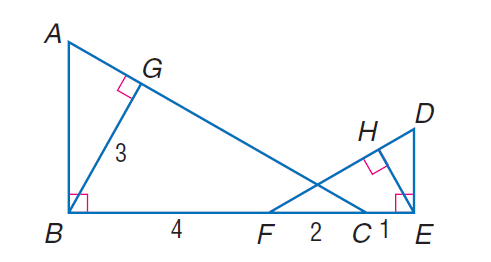Answer the mathemtical geometry problem and directly provide the correct option letter.
Question: Find E H if \triangle A B C \sim \triangle D E F, B G is an altitude of \triangle A B C, E H is an altitude of \triangle D E F, B G = 3, B F = 4, F C = 2, and C E = 1.
Choices: A: 1 B: \frac { 3 } { 2 } C: 2 D: 3 B 